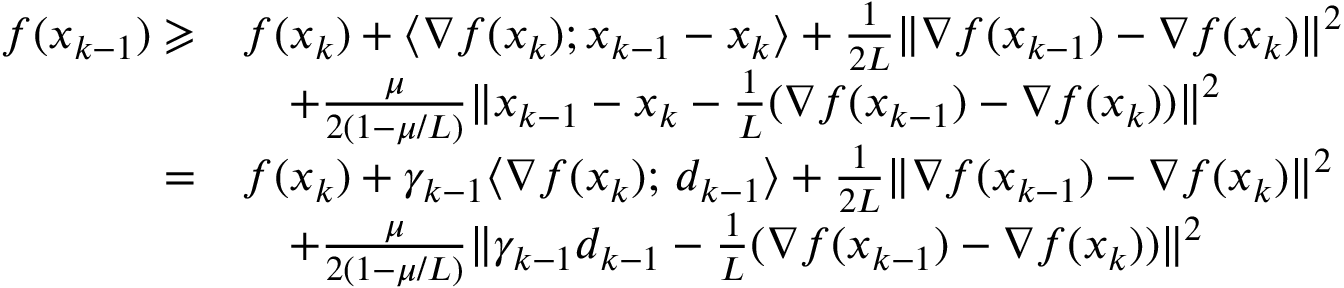<formula> <loc_0><loc_0><loc_500><loc_500>\begin{array} { r l } { f ( x _ { k - 1 } ) \geqslant } & { f ( x _ { k } ) + \langle \nabla f ( x _ { k } ) ; x _ { k - 1 } - x _ { k } \rangle + \frac { 1 } { 2 L } \| \nabla f ( x _ { k - 1 } ) - \nabla f ( x _ { k } ) \| ^ { 2 } } \\ & { \quad + \frac { \mu } { 2 ( 1 - \mu / L ) } \| x _ { k - 1 } - x _ { k } - \frac { 1 } { L } ( \nabla f ( x _ { k - 1 } ) - \nabla f ( x _ { k } ) ) \| ^ { 2 } } \\ { = } & { f ( x _ { k } ) + \gamma _ { k - 1 } \langle \nabla f ( x _ { k } ) ; \, d _ { k - 1 } \rangle + \frac { 1 } { 2 L } \| \nabla f ( x _ { k - 1 } ) - \nabla f ( x _ { k } ) \| ^ { 2 } } \\ & { \quad + \frac { \mu } { 2 ( 1 - \mu / L ) } \| \gamma _ { k - 1 } d _ { k - 1 } - \frac { 1 } { L } ( \nabla f ( x _ { k - 1 } ) - \nabla f ( x _ { k } ) ) \| ^ { 2 } } \end{array}</formula> 